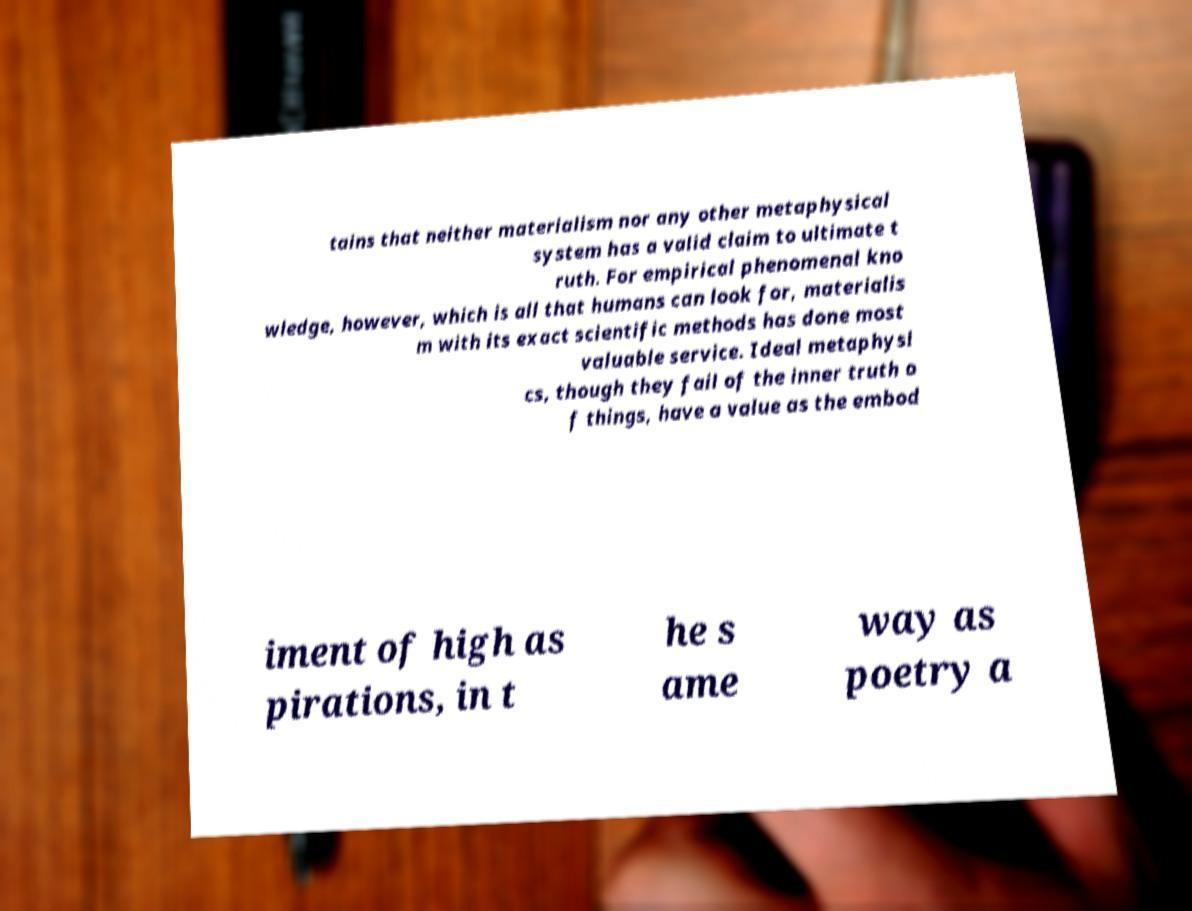What messages or text are displayed in this image? I need them in a readable, typed format. tains that neither materialism nor any other metaphysical system has a valid claim to ultimate t ruth. For empirical phenomenal kno wledge, however, which is all that humans can look for, materialis m with its exact scientific methods has done most valuable service. Ideal metaphysi cs, though they fail of the inner truth o f things, have a value as the embod iment of high as pirations, in t he s ame way as poetry a 